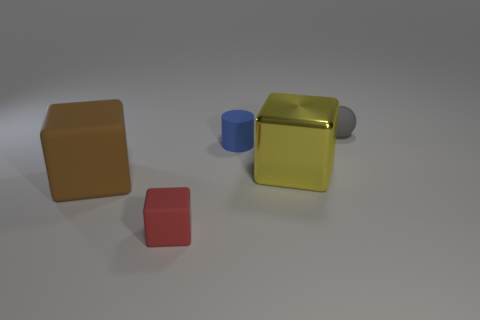Are there any other things that are the same material as the yellow thing?
Give a very brief answer. No. Does the tiny cylinder have the same material as the big object in front of the yellow block?
Give a very brief answer. Yes. Are there fewer large yellow blocks that are behind the yellow metallic object than tiny objects that are to the right of the tiny gray object?
Offer a terse response. No. What is the material of the big block that is left of the small red rubber object?
Your response must be concise. Rubber. There is a tiny matte object that is both to the left of the metal cube and behind the tiny red rubber block; what color is it?
Make the answer very short. Blue. What number of other objects are there of the same color as the metallic thing?
Your response must be concise. 0. There is a object on the right side of the shiny block; what is its color?
Give a very brief answer. Gray. Are there any gray objects of the same size as the cylinder?
Provide a succinct answer. Yes. There is a thing that is the same size as the yellow shiny cube; what is its material?
Keep it short and to the point. Rubber. What number of objects are objects behind the tiny rubber cylinder or blocks right of the brown matte thing?
Make the answer very short. 3. 